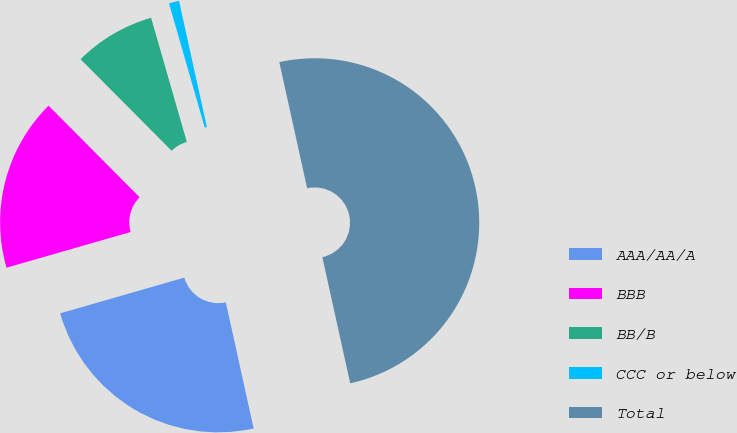<chart> <loc_0><loc_0><loc_500><loc_500><pie_chart><fcel>AAA/AA/A<fcel>BBB<fcel>BB/B<fcel>CCC or below<fcel>Total<nl><fcel>24.0%<fcel>17.0%<fcel>8.0%<fcel>1.0%<fcel>50.0%<nl></chart> 